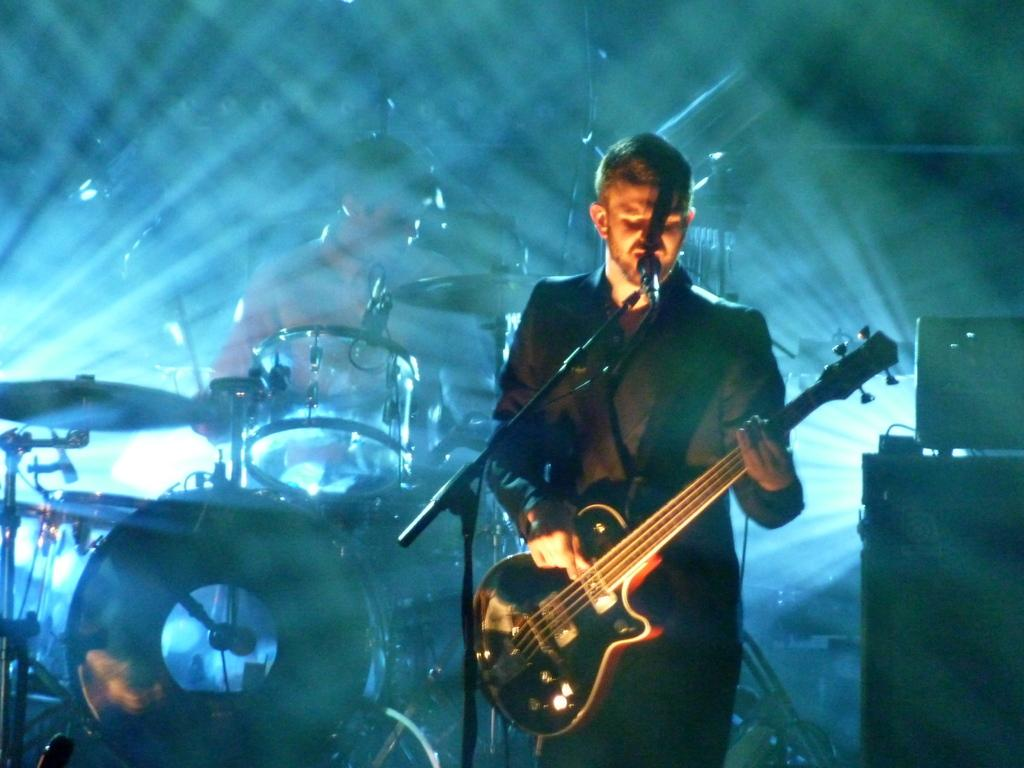What is the man on the right side of the image doing? The man on the right side of the image is playing the guitar and singing. What is the man on the left side of the image doing? The man on the left side of the image is beating the drums. Can you describe the activities of both men in the image? There is a man playing the guitar and singing on the right side, while a man is beating the drums on the left side. What type of wound can be seen on the man's hand while he is playing the guitar in the image? There is no wound visible on the man's hand in the image. Is there a park or square visible in the image? The image does not show a park or square; it only features the two men playing their respective instruments. 